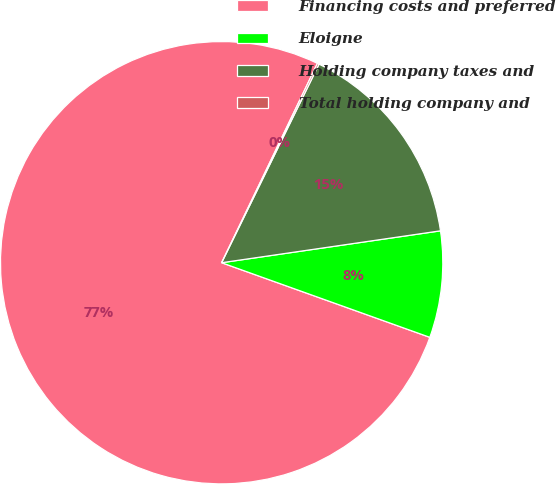<chart> <loc_0><loc_0><loc_500><loc_500><pie_chart><fcel>Financing costs and preferred<fcel>Eloigne<fcel>Holding company taxes and<fcel>Total holding company and<nl><fcel>76.65%<fcel>7.78%<fcel>15.44%<fcel>0.13%<nl></chart> 